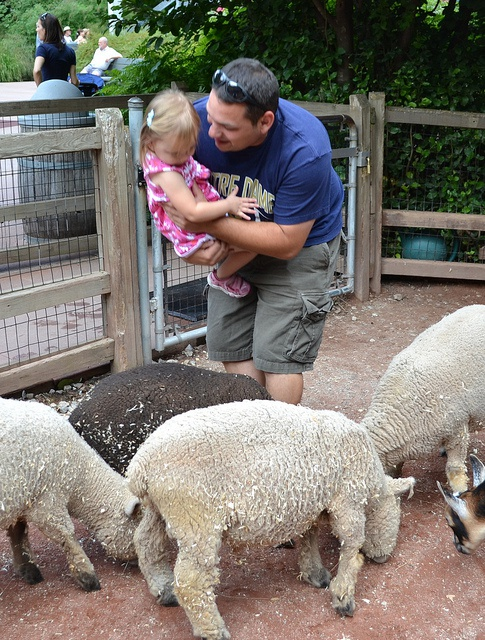Describe the objects in this image and their specific colors. I can see sheep in black, lightgray, darkgray, and tan tones, people in black, gray, navy, and darkgray tones, sheep in black, darkgray, lightgray, and gray tones, sheep in black, lightgray, darkgray, and gray tones, and people in black, brown, maroon, tan, and darkgray tones in this image. 